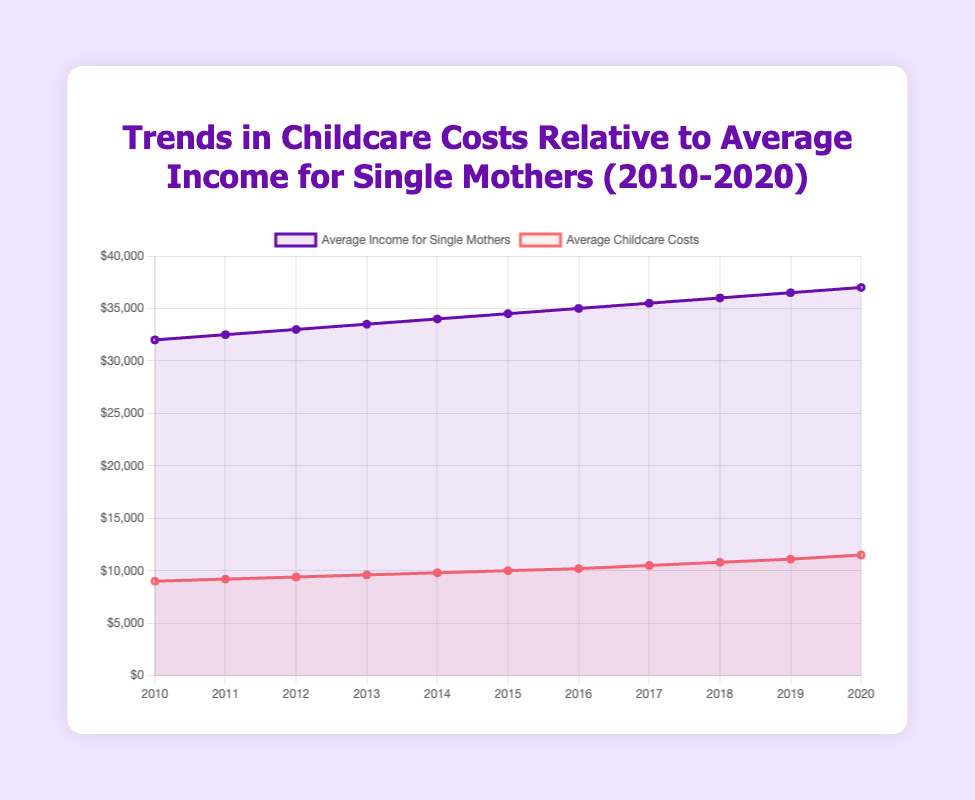What's the average increase in the average income for single mothers from 2010 to 2020? Compute the difference in average income from 2010 to 2020, which is $37,000 - $32,000 = $5,000. Since this span is 10 years, the average annual increase is $5,000 / 10 = $500 per year
Answer: $500 per year How much did the average childcare costs increase from 2010 to 2020? Calculate the difference in childcare costs from 2010 to 2020, which is $11,500 - $9,000 = $2,500
Answer: $2,500 In which year did the average childcare costs reach $10,000? From the data, the average childcare costs reached $10,000 in 2015
Answer: 2015 By how much did the average childcare costs grow compared to the average income for single mothers in 2020? The average childcare costs in 2020 were $11,500, and the average income was $37,000. The proportion can be calculated as $11,500 / $37,000 ≈ 0.31, or 31%
Answer: 31% From 2010 to 2020, what is the total increase in average income and childcare costs combined? Sum the total increase in average income ($5,000) and total increase in childcare costs ($2,500). That is $5,000 + $2,500 = $7,500
Answer: $7,500 In which year did the gap between average income and childcare costs exceed $25,000 for the first time? Calculate the gap for each year and check when it first exceeded $25,000: $32,000 - $9,000 = $23,000 (2010), $32,500 - $9,200 = $23,300 (2011), and so on. The gap first exceeded $25,000 in 2014: $34,000 - $9,800 = $24,200; 2015: $34,500 - $10,000 = $24,500; 2016: $35,000 - $10,200 = $24,800; 2017: $35,500 - $10,500 = $25,000; 2018: $36,000 - $10,800 = $25,200
Answer: 2018 Which line (representing average income or childcare costs) had more rapid growth over the decade? Calculate the growth rates for average income and childcare costs: Income increased by $37,000 - $32,000 = $5,000 on a base of $32,000, so the rate is $5,000 / $32,000 = 0.15625 (or ~15.6%). Childcare costs increased by $11,500 - $9,000 = $2,500 on a base of $9,000, so the rate is $2,500 / $9,000 ≈ 0.2778 (or ~27.8%). Childcare costs grew at a more rapid rate
Answer: Childcare costs Did the average income or childcare costs see a greater absolute increase from 2010 to 2020? Calculate the absolute increase in income ($5,000) and the absolute increase in childcare costs ($2,500) and compare them. $5,000 > $2,500, so the average income saw a greater absolute increase
Answer: Average income Are both lines on the graph increasing at a constant rate? Examine the increments each year; both lines reflect a consistent yearly increase with minor fluctuations, indicating constant rates. For average income, the increase is about $500 each year. For childcare costs, the increase is approximately $200 to $300 each year
Answer: Yes 